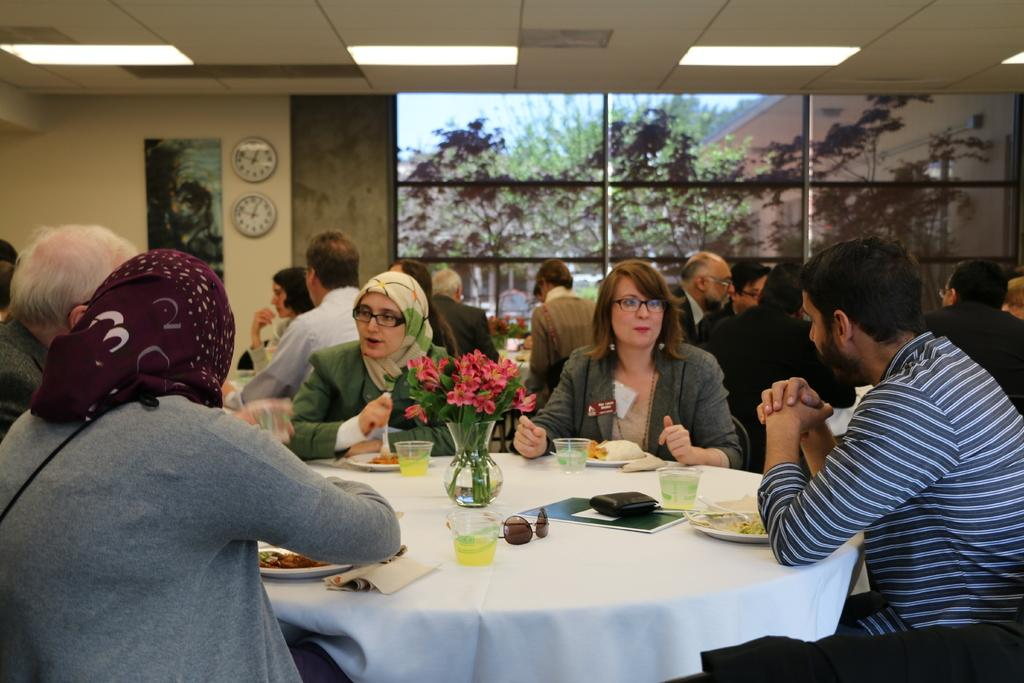What type of vegetation can be seen in the image? There are trees in the image. What time-telling devices are present on the wall? There are two clocks on the wall. What type of decoration is present in the image? There is a poster in the image. What are the people in the image doing? There are people sitting around tables. What items can be seen on the tables? There are glasses, a plant flask, and bowls on the tables. How many dogs are visible in the image? There are no dogs present in the image. What type of blade is being used by the people in the image? There is no blade being used by the people in the image. 